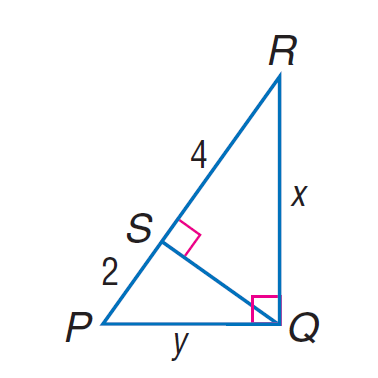Answer the mathemtical geometry problem and directly provide the correct option letter.
Question: Find y in \triangle P Q R.
Choices: A: 2 \sqrt { 3 } B: 2 \sqrt { 6 } C: 4 \sqrt { 3 } D: 4 \sqrt { 6 } A 